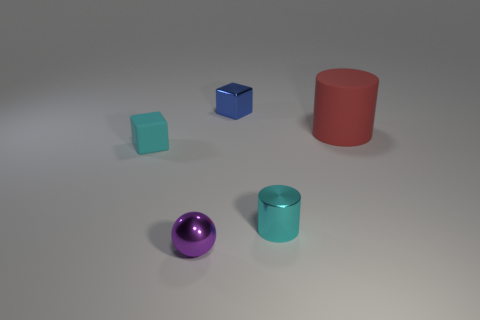Are there fewer large red objects than small yellow blocks?
Offer a very short reply. No. Are there any other brown rubber cylinders that have the same size as the rubber cylinder?
Ensure brevity in your answer.  No. There is a tiny purple shiny thing; does it have the same shape as the cyan object to the left of the blue thing?
Give a very brief answer. No. What number of blocks are either cyan objects or small cyan metal objects?
Provide a succinct answer. 1. What is the color of the metallic ball?
Offer a terse response. Purple. Is the number of purple metal balls greater than the number of tiny blocks?
Your response must be concise. No. How many things are either tiny objects behind the cyan cylinder or small cyan cubes?
Keep it short and to the point. 2. Is the material of the tiny cylinder the same as the blue object?
Offer a terse response. Yes. What size is the other object that is the same shape as the tiny blue thing?
Make the answer very short. Small. There is a cyan object on the left side of the small metallic sphere; does it have the same shape as the tiny thing that is behind the large matte cylinder?
Give a very brief answer. Yes. 